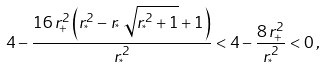<formula> <loc_0><loc_0><loc_500><loc_500>4 - \frac { 1 6 \, r _ { + } ^ { 2 } \left ( r _ { ^ { * } } ^ { 2 } - r _ { ^ { * } } \, \sqrt { r _ { ^ { * } } ^ { 2 } + 1 } + 1 \right ) } { r _ { ^ { * } } ^ { 2 } } < 4 - \frac { 8 \, r _ { + } ^ { 2 } } { r _ { ^ { * } } ^ { 2 } } < 0 \, ,</formula> 